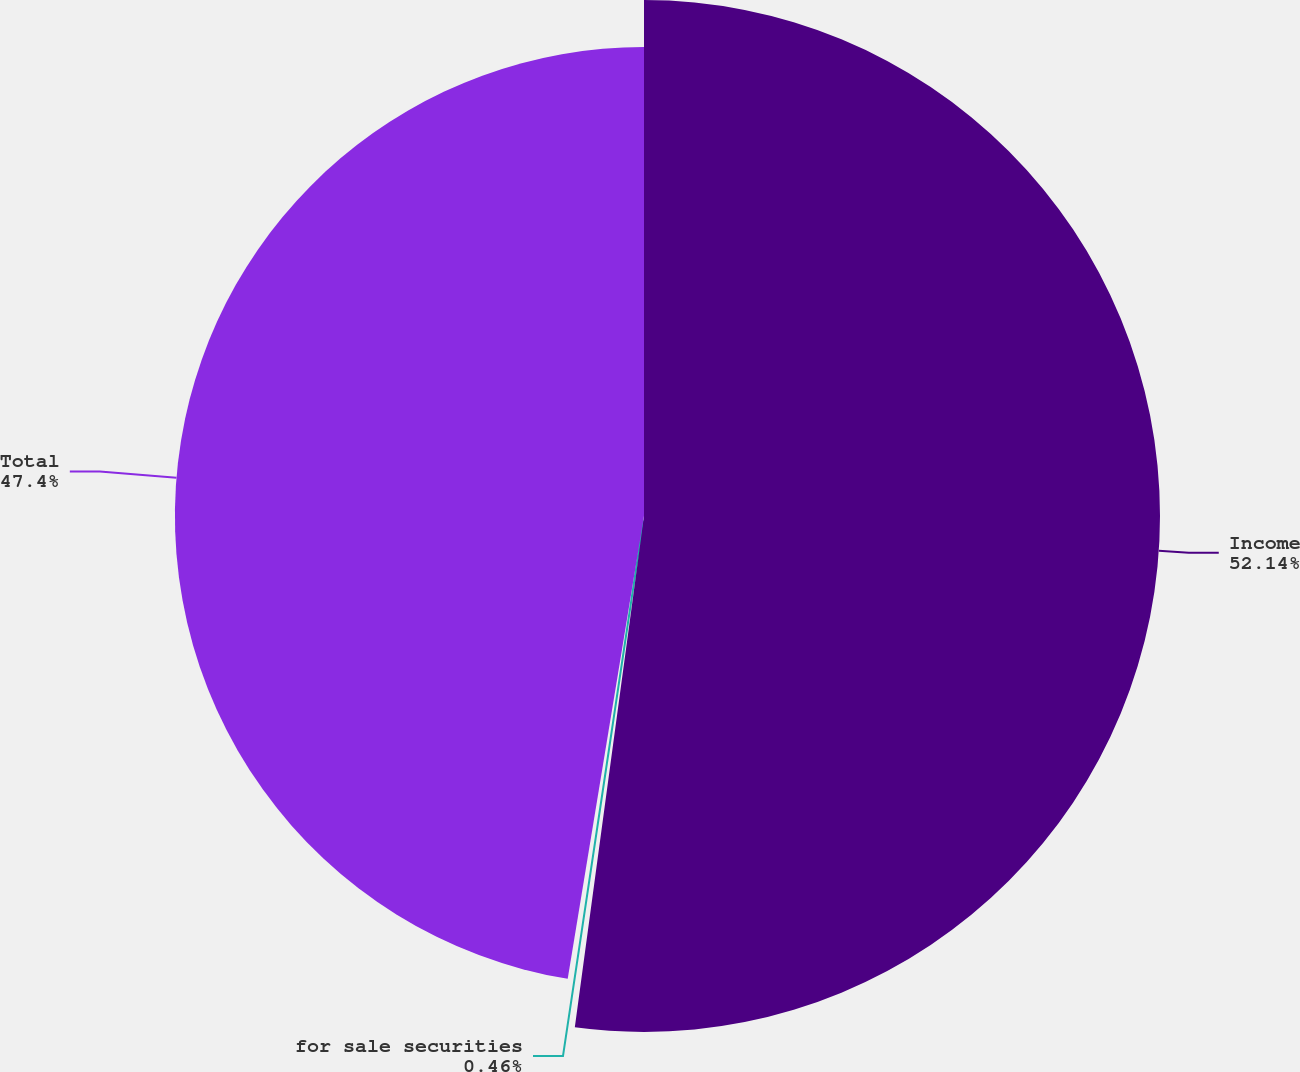Convert chart. <chart><loc_0><loc_0><loc_500><loc_500><pie_chart><fcel>Income<fcel>for sale securities<fcel>Total<nl><fcel>52.14%<fcel>0.46%<fcel>47.4%<nl></chart> 